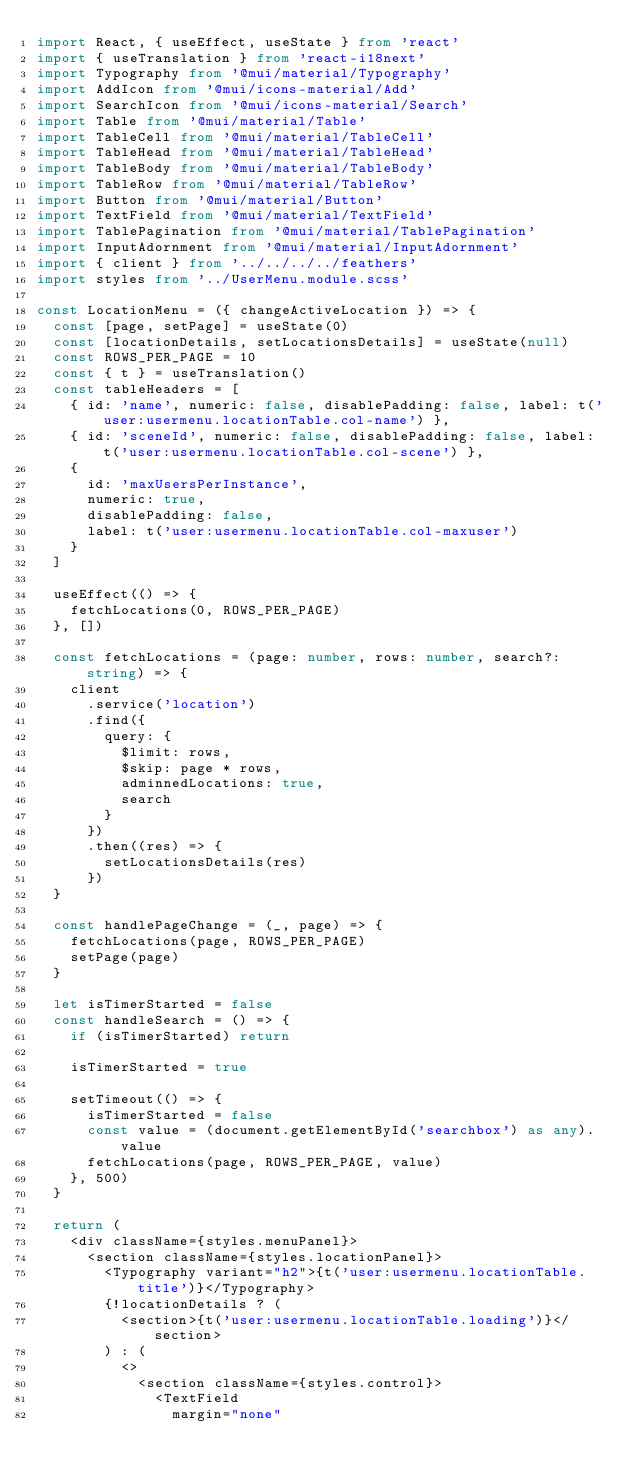Convert code to text. <code><loc_0><loc_0><loc_500><loc_500><_TypeScript_>import React, { useEffect, useState } from 'react'
import { useTranslation } from 'react-i18next'
import Typography from '@mui/material/Typography'
import AddIcon from '@mui/icons-material/Add'
import SearchIcon from '@mui/icons-material/Search'
import Table from '@mui/material/Table'
import TableCell from '@mui/material/TableCell'
import TableHead from '@mui/material/TableHead'
import TableBody from '@mui/material/TableBody'
import TableRow from '@mui/material/TableRow'
import Button from '@mui/material/Button'
import TextField from '@mui/material/TextField'
import TablePagination from '@mui/material/TablePagination'
import InputAdornment from '@mui/material/InputAdornment'
import { client } from '../../../../feathers'
import styles from '../UserMenu.module.scss'

const LocationMenu = ({ changeActiveLocation }) => {
  const [page, setPage] = useState(0)
  const [locationDetails, setLocationsDetails] = useState(null)
  const ROWS_PER_PAGE = 10
  const { t } = useTranslation()
  const tableHeaders = [
    { id: 'name', numeric: false, disablePadding: false, label: t('user:usermenu.locationTable.col-name') },
    { id: 'sceneId', numeric: false, disablePadding: false, label: t('user:usermenu.locationTable.col-scene') },
    {
      id: 'maxUsersPerInstance',
      numeric: true,
      disablePadding: false,
      label: t('user:usermenu.locationTable.col-maxuser')
    }
  ]

  useEffect(() => {
    fetchLocations(0, ROWS_PER_PAGE)
  }, [])

  const fetchLocations = (page: number, rows: number, search?: string) => {
    client
      .service('location')
      .find({
        query: {
          $limit: rows,
          $skip: page * rows,
          adminnedLocations: true,
          search
        }
      })
      .then((res) => {
        setLocationsDetails(res)
      })
  }

  const handlePageChange = (_, page) => {
    fetchLocations(page, ROWS_PER_PAGE)
    setPage(page)
  }

  let isTimerStarted = false
  const handleSearch = () => {
    if (isTimerStarted) return

    isTimerStarted = true

    setTimeout(() => {
      isTimerStarted = false
      const value = (document.getElementById('searchbox') as any).value
      fetchLocations(page, ROWS_PER_PAGE, value)
    }, 500)
  }

  return (
    <div className={styles.menuPanel}>
      <section className={styles.locationPanel}>
        <Typography variant="h2">{t('user:usermenu.locationTable.title')}</Typography>
        {!locationDetails ? (
          <section>{t('user:usermenu.locationTable.loading')}</section>
        ) : (
          <>
            <section className={styles.control}>
              <TextField
                margin="none"</code> 